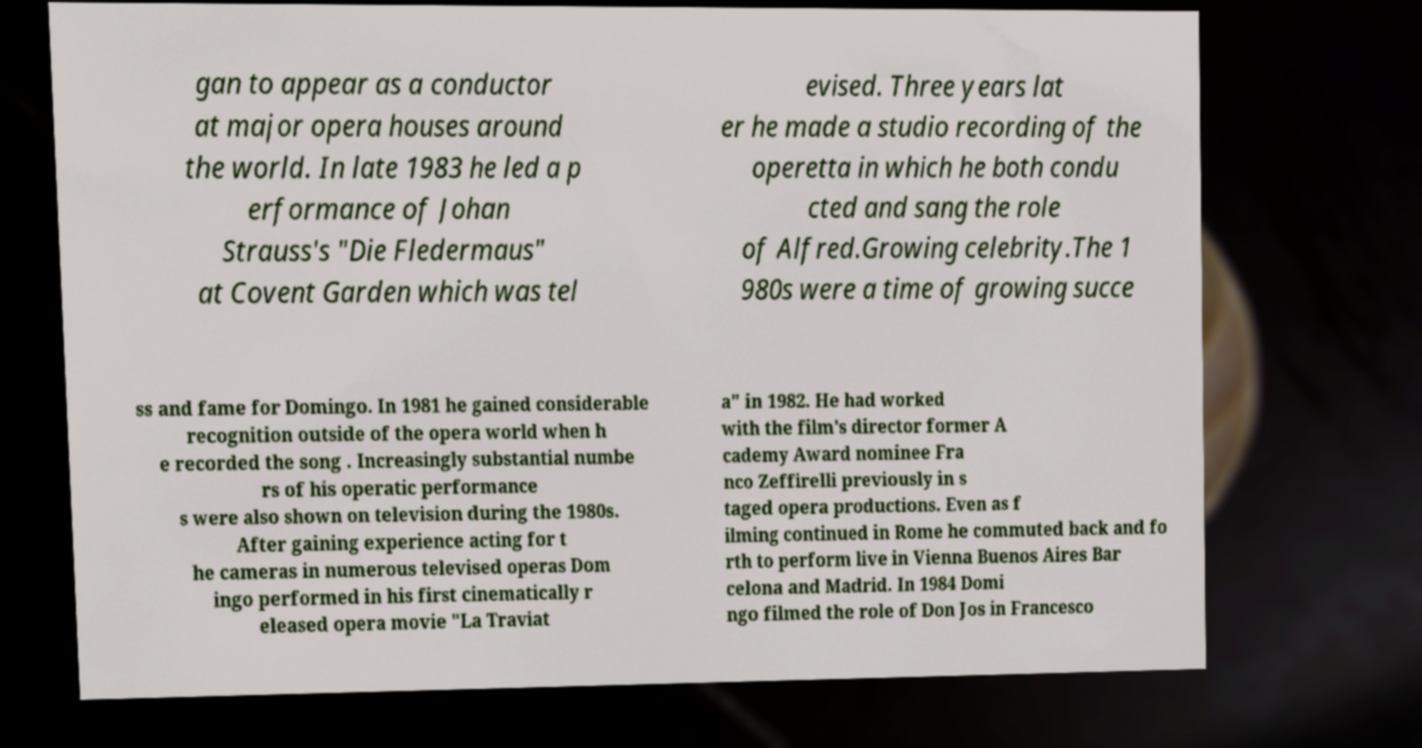Could you extract and type out the text from this image? gan to appear as a conductor at major opera houses around the world. In late 1983 he led a p erformance of Johan Strauss's "Die Fledermaus" at Covent Garden which was tel evised. Three years lat er he made a studio recording of the operetta in which he both condu cted and sang the role of Alfred.Growing celebrity.The 1 980s were a time of growing succe ss and fame for Domingo. In 1981 he gained considerable recognition outside of the opera world when h e recorded the song . Increasingly substantial numbe rs of his operatic performance s were also shown on television during the 1980s. After gaining experience acting for t he cameras in numerous televised operas Dom ingo performed in his first cinematically r eleased opera movie "La Traviat a" in 1982. He had worked with the film's director former A cademy Award nominee Fra nco Zeffirelli previously in s taged opera productions. Even as f ilming continued in Rome he commuted back and fo rth to perform live in Vienna Buenos Aires Bar celona and Madrid. In 1984 Domi ngo filmed the role of Don Jos in Francesco 